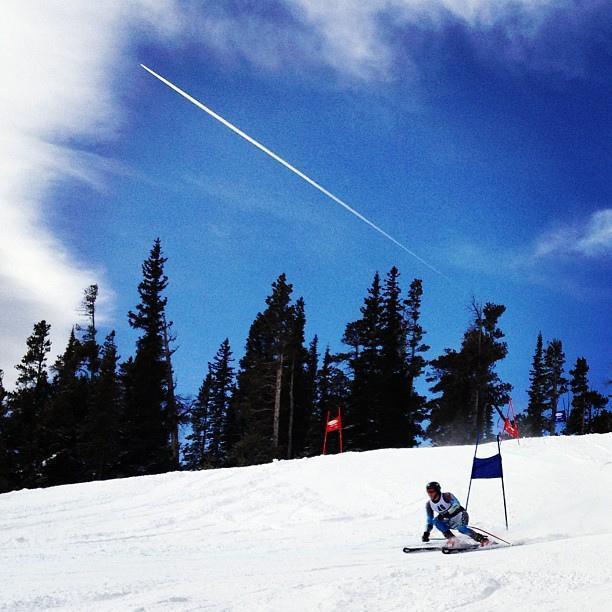How many motorcycles are between the sidewalk and the yellow line in the road?
Give a very brief answer. 0. 